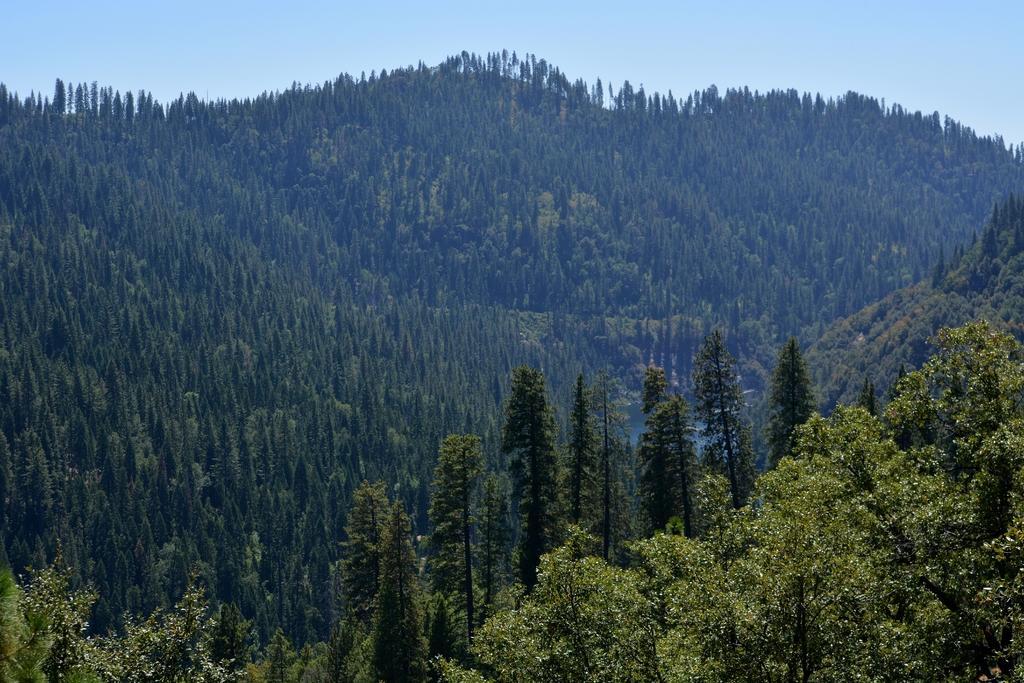How would you summarize this image in a sentence or two? In the foreground of this image, there are trees on mountains and on top there is the sky. 